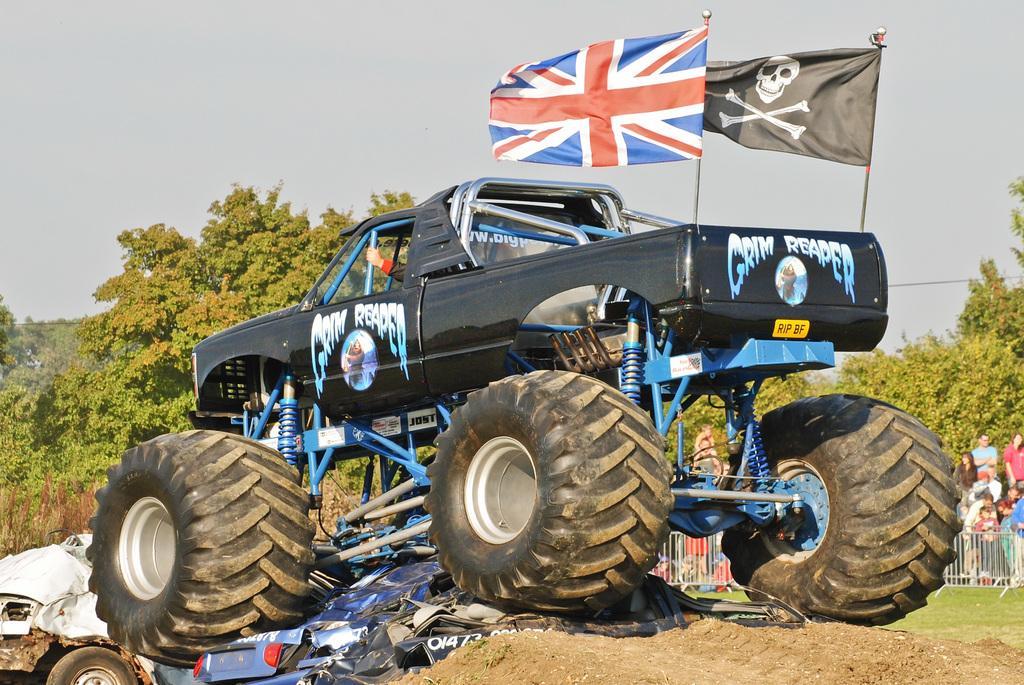Describe this image in one or two sentences. In the image there is a truck, it has huge wheels and the wheels are crushing some other vehicles, behind the truck there are a lot of trees and in front of those trees there is a crowd standing behind a fencing. 